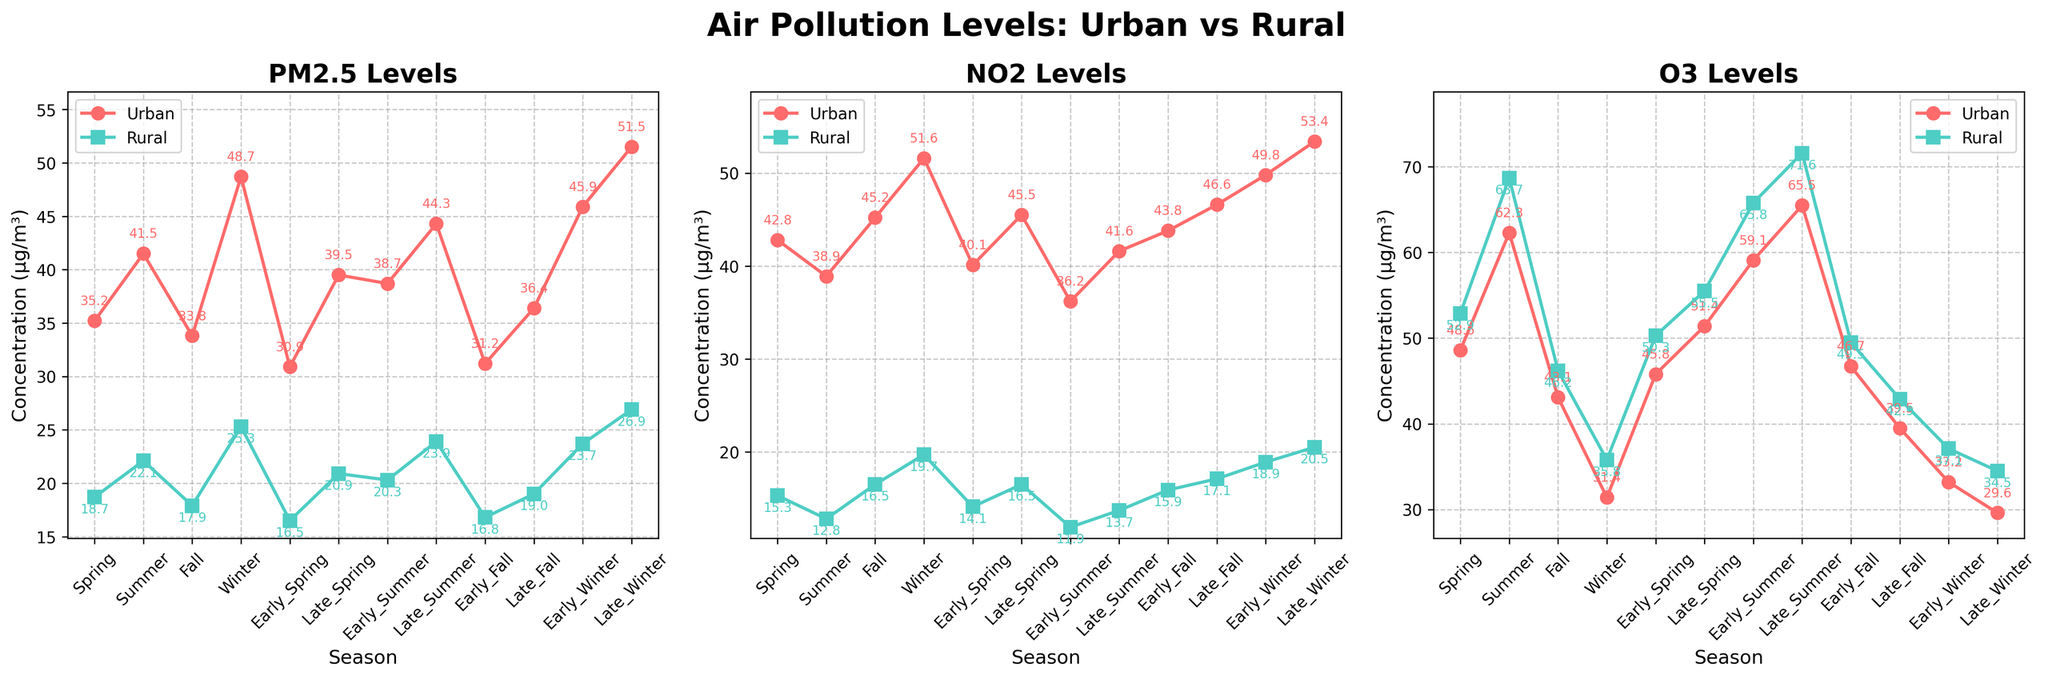What season exhibits the highest PM2.5 concentration in urban areas? Step-by-step explanation:
1. Refer to the urban PM2.5 subplot.
2. Compare the PM2.5 concentration values for each season.
3. Identify that the highest value is 51.5, which is in late winter.
Answer: Late Winter What is the difference between urban and rural NO2 concentrations in Early Spring? Step-by-step explanation:
1. Look at the NO2 subplot and find the values for Early Spring.
2. Urban NO2 in Early Spring: 40.1
3. Rural NO2 in Early Spring: 14.1
4. Calculate the difference: 40.1 - 14.1 = 26.0
Answer: 26.0 Which has a higher average O3 concentration in Summer, urban or rural areas? Step-by-step explanation:
1. Refer to the O3 subplot and find the values for Summer.
2. Urban O3 in Summer: 62.3
3. Rural O3 in Summer: 68.7
4. Calculate the average for each:
   - Urban average: 62.3
   - Rural average: 68.7
5. Compare the averages: 68.7 is higher.
Answer: Rural In which season is the difference between urban and rural PM2.5 concentrations the smallest? Step-by-step explanation:
1. Find the PM2.5 values for every season.
2. For each season, calculate the differences:
   - Spring: 35.2 - 18.7 = 16.5
   - Summer: 41.5 - 22.1 = 19.4
   - Fall: 33.8 - 17.9 = 15.9
   - Winter: 48.7 - 25.3 = 23.4
   - Early Spring: 30.9 - 16.5 = 14.4
   - Late Spring: 39.5 - 20.9 = 18.6
   - Early Summer: 38.7 - 20.3 = 18.4
   - Late Summer: 44.3 - 23.9 = 20.4
   - Early Fall: 31.2 - 16.8 = 14.4
   - Late Fall: 36.4 - 19.0 = 17.4
   - Early Winter: 45.9 - 23.7 = 22.2
   - Late Winter: 51.5 - 26.9 = 24.6
3. The smallest difference is 14.4, observed in both Early Spring and Early Fall.
Answer: Early Spring, Early Fall Are urban NO2 levels generally higher than rural NO2 levels across all seasons? Step-by-step explanation:
1. Look at the NO2 subplots and observe the levels for urban and rural areas.
2. Compare the values for each season:
   - Spring: 42.8 > 15.3
   - Summer: 38.9 > 12.8
   - Fall: 45.2 > 16.5
   - Winter: 51.6 > 19.7
   - Early Spring: 40.1 > 14.1
   - Late Spring: 45.5 > 16.5
   - Early Summer: 36.2 > 11.9
   - Late Summer: 41.6 > 13.7
   - Early Fall: 43.8 > 15.9
   - Late Fall: 46.6 > 17.1
   - Early Winter: 49.8 > 18.9
   - Late Winter: 53.4 > 20.5
3. Determine that urban levels are consistently higher than rural levels in every season.
Answer: Yes 